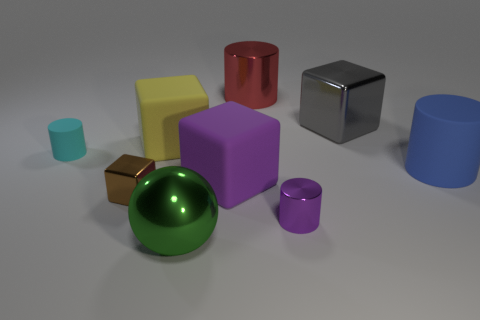Subtract all brown blocks. How many blocks are left? 3 Subtract all purple matte cubes. How many cubes are left? 3 Subtract 2 blocks. How many blocks are left? 2 Subtract all green cylinders. Subtract all red blocks. How many cylinders are left? 4 Subtract all cubes. How many objects are left? 5 Add 9 large purple metal objects. How many large purple metal objects exist? 9 Subtract 1 yellow cubes. How many objects are left? 8 Subtract all brown metallic blocks. Subtract all large metallic cubes. How many objects are left? 7 Add 5 tiny rubber objects. How many tiny rubber objects are left? 6 